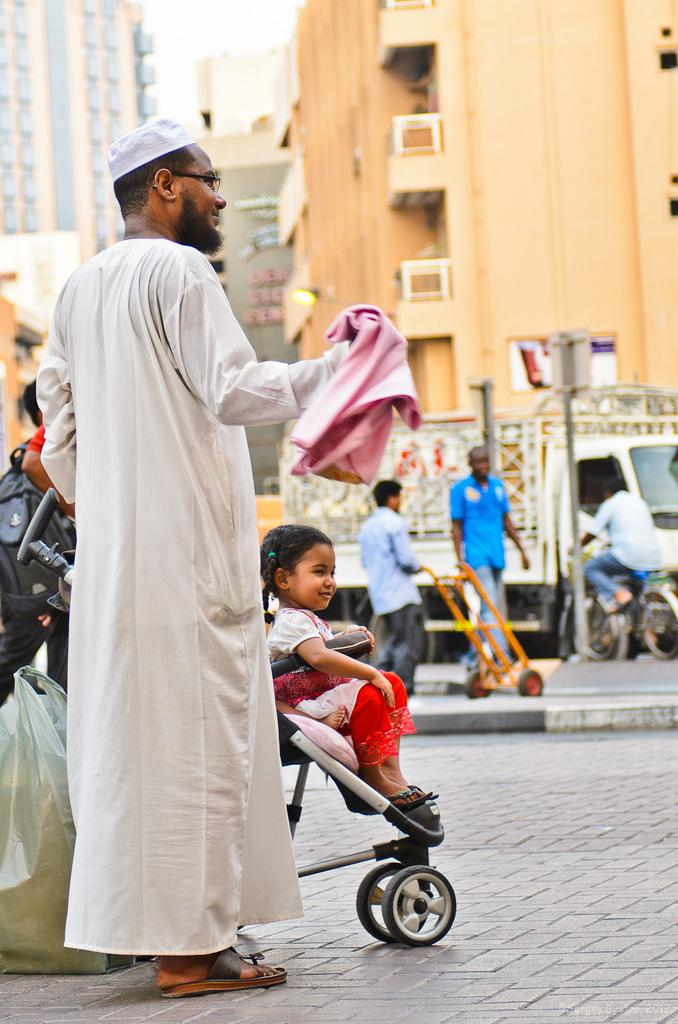What is the man doing in the image? The man is standing on the road with a child on wheels. What can be seen in the background of the image? There are buildings, a group of people, and a truck in the background. What type of vehicle is present in the background? There is a truck in the background. What type of yarn is the child using to jump in the image? There is no yarn or jumping activity present in the image. 